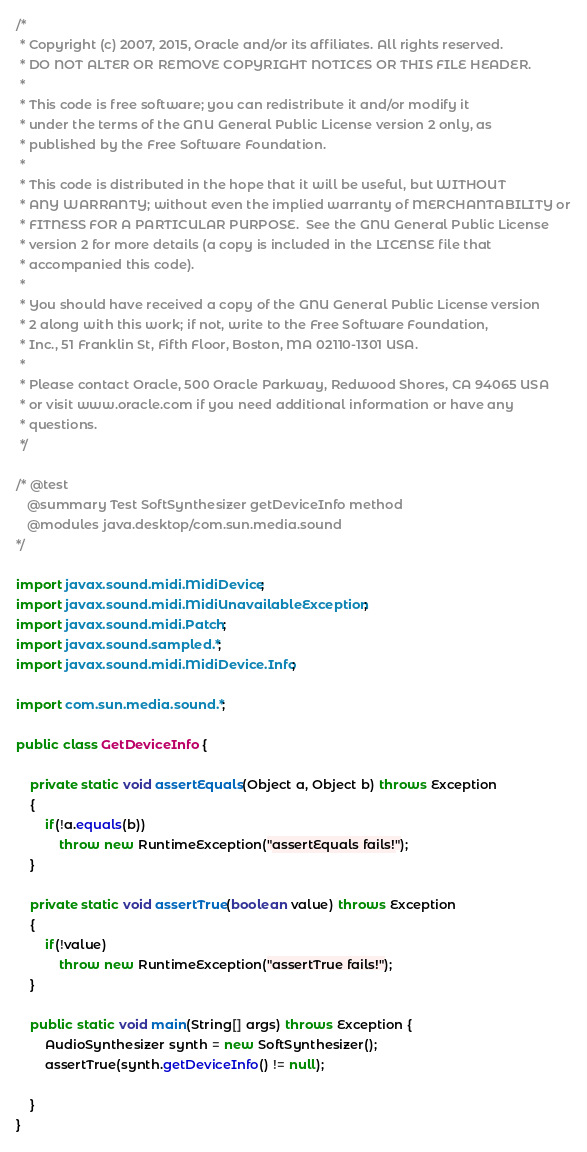<code> <loc_0><loc_0><loc_500><loc_500><_Java_>/*
 * Copyright (c) 2007, 2015, Oracle and/or its affiliates. All rights reserved.
 * DO NOT ALTER OR REMOVE COPYRIGHT NOTICES OR THIS FILE HEADER.
 *
 * This code is free software; you can redistribute it and/or modify it
 * under the terms of the GNU General Public License version 2 only, as
 * published by the Free Software Foundation.
 *
 * This code is distributed in the hope that it will be useful, but WITHOUT
 * ANY WARRANTY; without even the implied warranty of MERCHANTABILITY or
 * FITNESS FOR A PARTICULAR PURPOSE.  See the GNU General Public License
 * version 2 for more details (a copy is included in the LICENSE file that
 * accompanied this code).
 *
 * You should have received a copy of the GNU General Public License version
 * 2 along with this work; if not, write to the Free Software Foundation,
 * Inc., 51 Franklin St, Fifth Floor, Boston, MA 02110-1301 USA.
 *
 * Please contact Oracle, 500 Oracle Parkway, Redwood Shores, CA 94065 USA
 * or visit www.oracle.com if you need additional information or have any
 * questions.
 */

/* @test
   @summary Test SoftSynthesizer getDeviceInfo method
   @modules java.desktop/com.sun.media.sound
*/

import javax.sound.midi.MidiDevice;
import javax.sound.midi.MidiUnavailableException;
import javax.sound.midi.Patch;
import javax.sound.sampled.*;
import javax.sound.midi.MidiDevice.Info;

import com.sun.media.sound.*;

public class GetDeviceInfo {

    private static void assertEquals(Object a, Object b) throws Exception
    {
        if(!a.equals(b))
            throw new RuntimeException("assertEquals fails!");
    }

    private static void assertTrue(boolean value) throws Exception
    {
        if(!value)
            throw new RuntimeException("assertTrue fails!");
    }

    public static void main(String[] args) throws Exception {
        AudioSynthesizer synth = new SoftSynthesizer();
        assertTrue(synth.getDeviceInfo() != null);

    }
}
</code> 